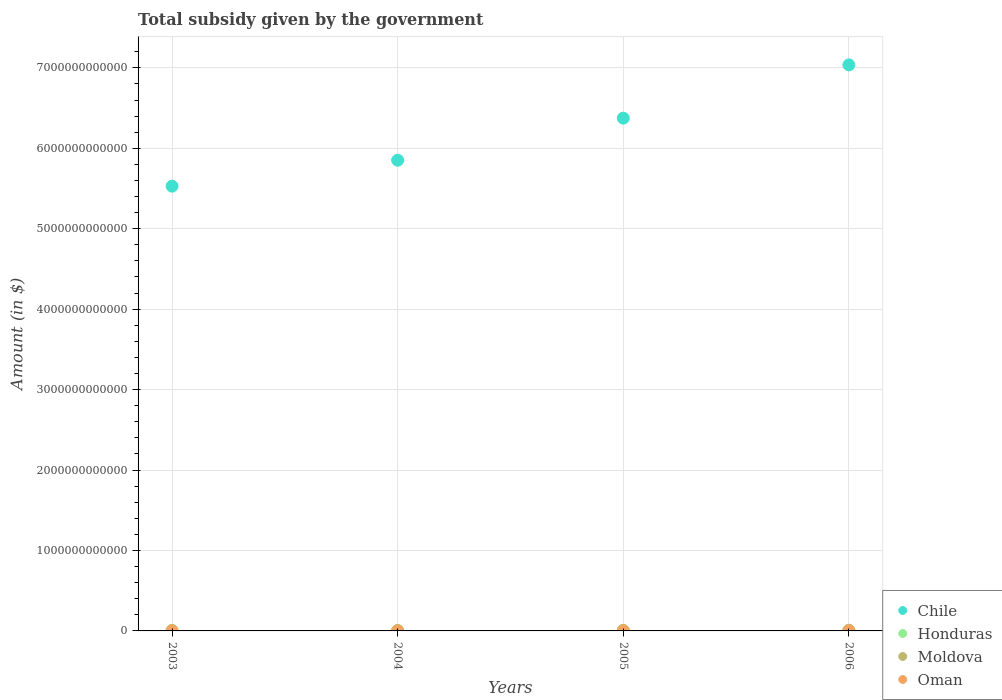What is the total revenue collected by the government in Moldova in 2005?
Make the answer very short. 5.88e+09. Across all years, what is the maximum total revenue collected by the government in Oman?
Your answer should be very brief. 3.06e+08. Across all years, what is the minimum total revenue collected by the government in Moldova?
Ensure brevity in your answer.  3.20e+09. In which year was the total revenue collected by the government in Oman maximum?
Provide a short and direct response. 2006. What is the total total revenue collected by the government in Chile in the graph?
Your answer should be compact. 2.48e+13. What is the difference between the total revenue collected by the government in Oman in 2005 and that in 2006?
Make the answer very short. -3.63e+07. What is the difference between the total revenue collected by the government in Chile in 2006 and the total revenue collected by the government in Honduras in 2004?
Give a very brief answer. 7.03e+12. What is the average total revenue collected by the government in Moldova per year?
Provide a short and direct response. 5.35e+09. In the year 2005, what is the difference between the total revenue collected by the government in Chile and total revenue collected by the government in Moldova?
Your answer should be very brief. 6.37e+12. In how many years, is the total revenue collected by the government in Honduras greater than 3000000000000 $?
Give a very brief answer. 0. What is the ratio of the total revenue collected by the government in Moldova in 2005 to that in 2006?
Your answer should be compact. 0.73. Is the total revenue collected by the government in Moldova in 2005 less than that in 2006?
Your answer should be compact. Yes. Is the difference between the total revenue collected by the government in Chile in 2005 and 2006 greater than the difference between the total revenue collected by the government in Moldova in 2005 and 2006?
Ensure brevity in your answer.  No. What is the difference between the highest and the second highest total revenue collected by the government in Oman?
Give a very brief answer. 3.63e+07. What is the difference between the highest and the lowest total revenue collected by the government in Moldova?
Offer a very short reply. 4.86e+09. What is the difference between two consecutive major ticks on the Y-axis?
Provide a succinct answer. 1.00e+12. Are the values on the major ticks of Y-axis written in scientific E-notation?
Make the answer very short. No. Does the graph contain grids?
Provide a short and direct response. Yes. How many legend labels are there?
Keep it short and to the point. 4. How are the legend labels stacked?
Your response must be concise. Vertical. What is the title of the graph?
Offer a terse response. Total subsidy given by the government. Does "Lao PDR" appear as one of the legend labels in the graph?
Keep it short and to the point. No. What is the label or title of the Y-axis?
Offer a very short reply. Amount (in $). What is the Amount (in $) in Chile in 2003?
Make the answer very short. 5.53e+12. What is the Amount (in $) of Honduras in 2003?
Your answer should be compact. 5.25e+09. What is the Amount (in $) in Moldova in 2003?
Ensure brevity in your answer.  3.20e+09. What is the Amount (in $) of Oman in 2003?
Ensure brevity in your answer.  1.15e+08. What is the Amount (in $) of Chile in 2004?
Keep it short and to the point. 5.85e+12. What is the Amount (in $) in Honduras in 2004?
Provide a succinct answer. 3.84e+09. What is the Amount (in $) in Moldova in 2004?
Give a very brief answer. 4.26e+09. What is the Amount (in $) in Oman in 2004?
Offer a very short reply. 1.60e+08. What is the Amount (in $) in Chile in 2005?
Keep it short and to the point. 6.38e+12. What is the Amount (in $) in Honduras in 2005?
Ensure brevity in your answer.  5.27e+09. What is the Amount (in $) in Moldova in 2005?
Give a very brief answer. 5.88e+09. What is the Amount (in $) in Oman in 2005?
Ensure brevity in your answer.  2.69e+08. What is the Amount (in $) of Chile in 2006?
Provide a succinct answer. 7.04e+12. What is the Amount (in $) of Honduras in 2006?
Your response must be concise. 4.83e+09. What is the Amount (in $) in Moldova in 2006?
Your answer should be compact. 8.06e+09. What is the Amount (in $) in Oman in 2006?
Offer a terse response. 3.06e+08. Across all years, what is the maximum Amount (in $) of Chile?
Keep it short and to the point. 7.04e+12. Across all years, what is the maximum Amount (in $) of Honduras?
Make the answer very short. 5.27e+09. Across all years, what is the maximum Amount (in $) of Moldova?
Make the answer very short. 8.06e+09. Across all years, what is the maximum Amount (in $) in Oman?
Ensure brevity in your answer.  3.06e+08. Across all years, what is the minimum Amount (in $) of Chile?
Provide a short and direct response. 5.53e+12. Across all years, what is the minimum Amount (in $) in Honduras?
Your answer should be very brief. 3.84e+09. Across all years, what is the minimum Amount (in $) of Moldova?
Ensure brevity in your answer.  3.20e+09. Across all years, what is the minimum Amount (in $) in Oman?
Make the answer very short. 1.15e+08. What is the total Amount (in $) in Chile in the graph?
Provide a succinct answer. 2.48e+13. What is the total Amount (in $) of Honduras in the graph?
Your answer should be compact. 1.92e+1. What is the total Amount (in $) in Moldova in the graph?
Offer a very short reply. 2.14e+1. What is the total Amount (in $) of Oman in the graph?
Your answer should be compact. 8.50e+08. What is the difference between the Amount (in $) in Chile in 2003 and that in 2004?
Keep it short and to the point. -3.22e+11. What is the difference between the Amount (in $) in Honduras in 2003 and that in 2004?
Your response must be concise. 1.41e+09. What is the difference between the Amount (in $) of Moldova in 2003 and that in 2004?
Provide a short and direct response. -1.06e+09. What is the difference between the Amount (in $) in Oman in 2003 and that in 2004?
Your answer should be very brief. -4.54e+07. What is the difference between the Amount (in $) in Chile in 2003 and that in 2005?
Provide a short and direct response. -8.46e+11. What is the difference between the Amount (in $) of Honduras in 2003 and that in 2005?
Offer a very short reply. -1.57e+07. What is the difference between the Amount (in $) in Moldova in 2003 and that in 2005?
Give a very brief answer. -2.68e+09. What is the difference between the Amount (in $) of Oman in 2003 and that in 2005?
Your response must be concise. -1.54e+08. What is the difference between the Amount (in $) of Chile in 2003 and that in 2006?
Your answer should be compact. -1.51e+12. What is the difference between the Amount (in $) of Honduras in 2003 and that in 2006?
Offer a very short reply. 4.17e+08. What is the difference between the Amount (in $) in Moldova in 2003 and that in 2006?
Your answer should be very brief. -4.86e+09. What is the difference between the Amount (in $) of Oman in 2003 and that in 2006?
Offer a very short reply. -1.91e+08. What is the difference between the Amount (in $) in Chile in 2004 and that in 2005?
Your answer should be compact. -5.23e+11. What is the difference between the Amount (in $) in Honduras in 2004 and that in 2005?
Give a very brief answer. -1.43e+09. What is the difference between the Amount (in $) of Moldova in 2004 and that in 2005?
Give a very brief answer. -1.62e+09. What is the difference between the Amount (in $) of Oman in 2004 and that in 2005?
Keep it short and to the point. -1.09e+08. What is the difference between the Amount (in $) of Chile in 2004 and that in 2006?
Keep it short and to the point. -1.19e+12. What is the difference between the Amount (in $) in Honduras in 2004 and that in 2006?
Provide a succinct answer. -9.93e+08. What is the difference between the Amount (in $) in Moldova in 2004 and that in 2006?
Give a very brief answer. -3.80e+09. What is the difference between the Amount (in $) of Oman in 2004 and that in 2006?
Provide a short and direct response. -1.45e+08. What is the difference between the Amount (in $) in Chile in 2005 and that in 2006?
Provide a short and direct response. -6.62e+11. What is the difference between the Amount (in $) in Honduras in 2005 and that in 2006?
Give a very brief answer. 4.33e+08. What is the difference between the Amount (in $) in Moldova in 2005 and that in 2006?
Offer a very short reply. -2.18e+09. What is the difference between the Amount (in $) in Oman in 2005 and that in 2006?
Provide a short and direct response. -3.63e+07. What is the difference between the Amount (in $) in Chile in 2003 and the Amount (in $) in Honduras in 2004?
Provide a short and direct response. 5.53e+12. What is the difference between the Amount (in $) in Chile in 2003 and the Amount (in $) in Moldova in 2004?
Keep it short and to the point. 5.53e+12. What is the difference between the Amount (in $) in Chile in 2003 and the Amount (in $) in Oman in 2004?
Ensure brevity in your answer.  5.53e+12. What is the difference between the Amount (in $) of Honduras in 2003 and the Amount (in $) of Moldova in 2004?
Offer a terse response. 9.91e+08. What is the difference between the Amount (in $) of Honduras in 2003 and the Amount (in $) of Oman in 2004?
Give a very brief answer. 5.09e+09. What is the difference between the Amount (in $) of Moldova in 2003 and the Amount (in $) of Oman in 2004?
Your answer should be compact. 3.04e+09. What is the difference between the Amount (in $) in Chile in 2003 and the Amount (in $) in Honduras in 2005?
Offer a terse response. 5.52e+12. What is the difference between the Amount (in $) of Chile in 2003 and the Amount (in $) of Moldova in 2005?
Keep it short and to the point. 5.52e+12. What is the difference between the Amount (in $) of Chile in 2003 and the Amount (in $) of Oman in 2005?
Your answer should be compact. 5.53e+12. What is the difference between the Amount (in $) in Honduras in 2003 and the Amount (in $) in Moldova in 2005?
Your answer should be very brief. -6.29e+08. What is the difference between the Amount (in $) in Honduras in 2003 and the Amount (in $) in Oman in 2005?
Offer a very short reply. 4.98e+09. What is the difference between the Amount (in $) of Moldova in 2003 and the Amount (in $) of Oman in 2005?
Provide a succinct answer. 2.93e+09. What is the difference between the Amount (in $) of Chile in 2003 and the Amount (in $) of Honduras in 2006?
Your answer should be very brief. 5.52e+12. What is the difference between the Amount (in $) in Chile in 2003 and the Amount (in $) in Moldova in 2006?
Your answer should be compact. 5.52e+12. What is the difference between the Amount (in $) of Chile in 2003 and the Amount (in $) of Oman in 2006?
Provide a succinct answer. 5.53e+12. What is the difference between the Amount (in $) in Honduras in 2003 and the Amount (in $) in Moldova in 2006?
Give a very brief answer. -2.81e+09. What is the difference between the Amount (in $) of Honduras in 2003 and the Amount (in $) of Oman in 2006?
Ensure brevity in your answer.  4.95e+09. What is the difference between the Amount (in $) in Moldova in 2003 and the Amount (in $) in Oman in 2006?
Make the answer very short. 2.90e+09. What is the difference between the Amount (in $) in Chile in 2004 and the Amount (in $) in Honduras in 2005?
Offer a very short reply. 5.85e+12. What is the difference between the Amount (in $) in Chile in 2004 and the Amount (in $) in Moldova in 2005?
Keep it short and to the point. 5.85e+12. What is the difference between the Amount (in $) of Chile in 2004 and the Amount (in $) of Oman in 2005?
Provide a short and direct response. 5.85e+12. What is the difference between the Amount (in $) in Honduras in 2004 and the Amount (in $) in Moldova in 2005?
Keep it short and to the point. -2.04e+09. What is the difference between the Amount (in $) in Honduras in 2004 and the Amount (in $) in Oman in 2005?
Your response must be concise. 3.57e+09. What is the difference between the Amount (in $) in Moldova in 2004 and the Amount (in $) in Oman in 2005?
Give a very brief answer. 3.99e+09. What is the difference between the Amount (in $) of Chile in 2004 and the Amount (in $) of Honduras in 2006?
Provide a succinct answer. 5.85e+12. What is the difference between the Amount (in $) of Chile in 2004 and the Amount (in $) of Moldova in 2006?
Provide a succinct answer. 5.84e+12. What is the difference between the Amount (in $) in Chile in 2004 and the Amount (in $) in Oman in 2006?
Provide a short and direct response. 5.85e+12. What is the difference between the Amount (in $) in Honduras in 2004 and the Amount (in $) in Moldova in 2006?
Keep it short and to the point. -4.22e+09. What is the difference between the Amount (in $) of Honduras in 2004 and the Amount (in $) of Oman in 2006?
Offer a terse response. 3.54e+09. What is the difference between the Amount (in $) of Moldova in 2004 and the Amount (in $) of Oman in 2006?
Provide a succinct answer. 3.95e+09. What is the difference between the Amount (in $) of Chile in 2005 and the Amount (in $) of Honduras in 2006?
Offer a very short reply. 6.37e+12. What is the difference between the Amount (in $) in Chile in 2005 and the Amount (in $) in Moldova in 2006?
Give a very brief answer. 6.37e+12. What is the difference between the Amount (in $) of Chile in 2005 and the Amount (in $) of Oman in 2006?
Provide a short and direct response. 6.37e+12. What is the difference between the Amount (in $) in Honduras in 2005 and the Amount (in $) in Moldova in 2006?
Provide a succinct answer. -2.80e+09. What is the difference between the Amount (in $) in Honduras in 2005 and the Amount (in $) in Oman in 2006?
Make the answer very short. 4.96e+09. What is the difference between the Amount (in $) of Moldova in 2005 and the Amount (in $) of Oman in 2006?
Your answer should be very brief. 5.57e+09. What is the average Amount (in $) in Chile per year?
Give a very brief answer. 6.20e+12. What is the average Amount (in $) of Honduras per year?
Give a very brief answer. 4.80e+09. What is the average Amount (in $) of Moldova per year?
Provide a succinct answer. 5.35e+09. What is the average Amount (in $) of Oman per year?
Keep it short and to the point. 2.12e+08. In the year 2003, what is the difference between the Amount (in $) of Chile and Amount (in $) of Honduras?
Provide a short and direct response. 5.52e+12. In the year 2003, what is the difference between the Amount (in $) of Chile and Amount (in $) of Moldova?
Offer a very short reply. 5.53e+12. In the year 2003, what is the difference between the Amount (in $) of Chile and Amount (in $) of Oman?
Give a very brief answer. 5.53e+12. In the year 2003, what is the difference between the Amount (in $) in Honduras and Amount (in $) in Moldova?
Offer a terse response. 2.05e+09. In the year 2003, what is the difference between the Amount (in $) in Honduras and Amount (in $) in Oman?
Your answer should be compact. 5.14e+09. In the year 2003, what is the difference between the Amount (in $) in Moldova and Amount (in $) in Oman?
Provide a succinct answer. 3.09e+09. In the year 2004, what is the difference between the Amount (in $) in Chile and Amount (in $) in Honduras?
Your answer should be compact. 5.85e+12. In the year 2004, what is the difference between the Amount (in $) of Chile and Amount (in $) of Moldova?
Ensure brevity in your answer.  5.85e+12. In the year 2004, what is the difference between the Amount (in $) in Chile and Amount (in $) in Oman?
Offer a very short reply. 5.85e+12. In the year 2004, what is the difference between the Amount (in $) of Honduras and Amount (in $) of Moldova?
Make the answer very short. -4.19e+08. In the year 2004, what is the difference between the Amount (in $) of Honduras and Amount (in $) of Oman?
Give a very brief answer. 3.68e+09. In the year 2004, what is the difference between the Amount (in $) in Moldova and Amount (in $) in Oman?
Provide a short and direct response. 4.10e+09. In the year 2005, what is the difference between the Amount (in $) of Chile and Amount (in $) of Honduras?
Make the answer very short. 6.37e+12. In the year 2005, what is the difference between the Amount (in $) in Chile and Amount (in $) in Moldova?
Make the answer very short. 6.37e+12. In the year 2005, what is the difference between the Amount (in $) of Chile and Amount (in $) of Oman?
Offer a very short reply. 6.37e+12. In the year 2005, what is the difference between the Amount (in $) in Honduras and Amount (in $) in Moldova?
Offer a terse response. -6.13e+08. In the year 2005, what is the difference between the Amount (in $) in Honduras and Amount (in $) in Oman?
Offer a terse response. 5.00e+09. In the year 2005, what is the difference between the Amount (in $) in Moldova and Amount (in $) in Oman?
Offer a terse response. 5.61e+09. In the year 2006, what is the difference between the Amount (in $) of Chile and Amount (in $) of Honduras?
Give a very brief answer. 7.03e+12. In the year 2006, what is the difference between the Amount (in $) in Chile and Amount (in $) in Moldova?
Your answer should be very brief. 7.03e+12. In the year 2006, what is the difference between the Amount (in $) of Chile and Amount (in $) of Oman?
Offer a terse response. 7.04e+12. In the year 2006, what is the difference between the Amount (in $) in Honduras and Amount (in $) in Moldova?
Offer a very short reply. -3.23e+09. In the year 2006, what is the difference between the Amount (in $) in Honduras and Amount (in $) in Oman?
Your response must be concise. 4.53e+09. In the year 2006, what is the difference between the Amount (in $) of Moldova and Amount (in $) of Oman?
Provide a succinct answer. 7.76e+09. What is the ratio of the Amount (in $) of Chile in 2003 to that in 2004?
Provide a succinct answer. 0.94. What is the ratio of the Amount (in $) in Honduras in 2003 to that in 2004?
Offer a terse response. 1.37. What is the ratio of the Amount (in $) in Moldova in 2003 to that in 2004?
Your response must be concise. 0.75. What is the ratio of the Amount (in $) of Oman in 2003 to that in 2004?
Keep it short and to the point. 0.72. What is the ratio of the Amount (in $) of Chile in 2003 to that in 2005?
Offer a terse response. 0.87. What is the ratio of the Amount (in $) in Moldova in 2003 to that in 2005?
Offer a very short reply. 0.54. What is the ratio of the Amount (in $) in Oman in 2003 to that in 2005?
Offer a terse response. 0.43. What is the ratio of the Amount (in $) of Chile in 2003 to that in 2006?
Ensure brevity in your answer.  0.79. What is the ratio of the Amount (in $) of Honduras in 2003 to that in 2006?
Offer a very short reply. 1.09. What is the ratio of the Amount (in $) in Moldova in 2003 to that in 2006?
Keep it short and to the point. 0.4. What is the ratio of the Amount (in $) in Oman in 2003 to that in 2006?
Provide a short and direct response. 0.38. What is the ratio of the Amount (in $) in Chile in 2004 to that in 2005?
Provide a short and direct response. 0.92. What is the ratio of the Amount (in $) of Honduras in 2004 to that in 2005?
Offer a terse response. 0.73. What is the ratio of the Amount (in $) of Moldova in 2004 to that in 2005?
Your answer should be compact. 0.72. What is the ratio of the Amount (in $) of Oman in 2004 to that in 2005?
Keep it short and to the point. 0.59. What is the ratio of the Amount (in $) in Chile in 2004 to that in 2006?
Provide a succinct answer. 0.83. What is the ratio of the Amount (in $) in Honduras in 2004 to that in 2006?
Provide a succinct answer. 0.79. What is the ratio of the Amount (in $) in Moldova in 2004 to that in 2006?
Provide a succinct answer. 0.53. What is the ratio of the Amount (in $) in Oman in 2004 to that in 2006?
Offer a very short reply. 0.52. What is the ratio of the Amount (in $) of Chile in 2005 to that in 2006?
Offer a very short reply. 0.91. What is the ratio of the Amount (in $) of Honduras in 2005 to that in 2006?
Your answer should be very brief. 1.09. What is the ratio of the Amount (in $) in Moldova in 2005 to that in 2006?
Ensure brevity in your answer.  0.73. What is the ratio of the Amount (in $) of Oman in 2005 to that in 2006?
Your response must be concise. 0.88. What is the difference between the highest and the second highest Amount (in $) in Chile?
Ensure brevity in your answer.  6.62e+11. What is the difference between the highest and the second highest Amount (in $) of Honduras?
Offer a terse response. 1.57e+07. What is the difference between the highest and the second highest Amount (in $) in Moldova?
Offer a terse response. 2.18e+09. What is the difference between the highest and the second highest Amount (in $) in Oman?
Make the answer very short. 3.63e+07. What is the difference between the highest and the lowest Amount (in $) in Chile?
Offer a terse response. 1.51e+12. What is the difference between the highest and the lowest Amount (in $) of Honduras?
Offer a very short reply. 1.43e+09. What is the difference between the highest and the lowest Amount (in $) of Moldova?
Keep it short and to the point. 4.86e+09. What is the difference between the highest and the lowest Amount (in $) of Oman?
Offer a very short reply. 1.91e+08. 